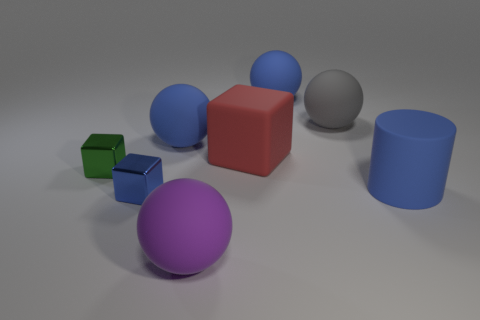Add 1 large gray rubber cylinders. How many objects exist? 9 Subtract all cylinders. How many objects are left? 7 Subtract all small cyan objects. Subtract all gray things. How many objects are left? 7 Add 3 blue metal cubes. How many blue metal cubes are left? 4 Add 6 large gray rubber things. How many large gray rubber things exist? 7 Subtract 0 yellow blocks. How many objects are left? 8 